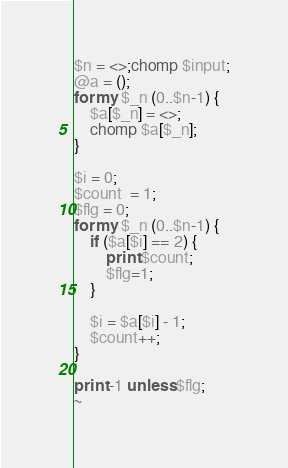<code> <loc_0><loc_0><loc_500><loc_500><_Perl_>$n = <>;chomp $input;
@a = ();
for my $_n (0..$n-1) {
    $a[$_n] = <>;
    chomp $a[$_n];
}

$i = 0;
$count  = 1;
$flg = 0;
for my $_n (0..$n-1) {
    if ($a[$i] == 2) {
        print $count;
        $flg=1;
    }

    $i = $a[$i] - 1;
    $count++;
}

print -1 unless $flg;
~</code> 